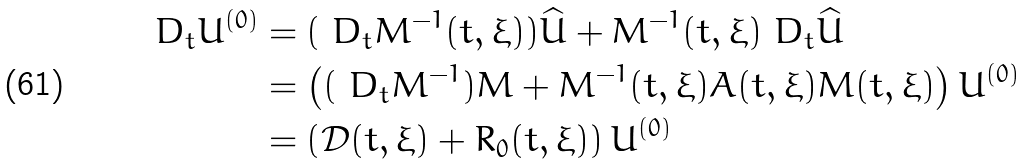<formula> <loc_0><loc_0><loc_500><loc_500>D _ { t } U ^ { ( 0 ) } & = ( \ D _ { t } M ^ { - 1 } ( t , \xi ) ) \widehat { U } + M ^ { - 1 } ( t , \xi ) \ D _ { t } \widehat { U } \\ & = \left ( ( \ D _ { t } M ^ { - 1 } ) M + M ^ { - 1 } ( t , \xi ) A ( t , \xi ) M ( t , \xi ) \right ) U ^ { ( 0 ) } \\ & = \left ( \mathcal { D } ( t , \xi ) + R _ { 0 } ( t , \xi ) \right ) U ^ { ( 0 ) }</formula> 